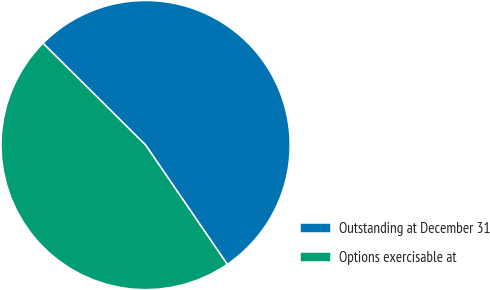Convert chart to OTSL. <chart><loc_0><loc_0><loc_500><loc_500><pie_chart><fcel>Outstanding at December 31<fcel>Options exercisable at<nl><fcel>53.01%<fcel>46.99%<nl></chart> 